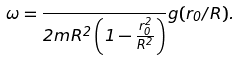Convert formula to latex. <formula><loc_0><loc_0><loc_500><loc_500>\omega = \frac { } { 2 m R ^ { 2 } \left ( 1 - \frac { r _ { 0 } ^ { 2 } } { R ^ { 2 } } \right ) } g ( r _ { 0 } / R ) .</formula> 